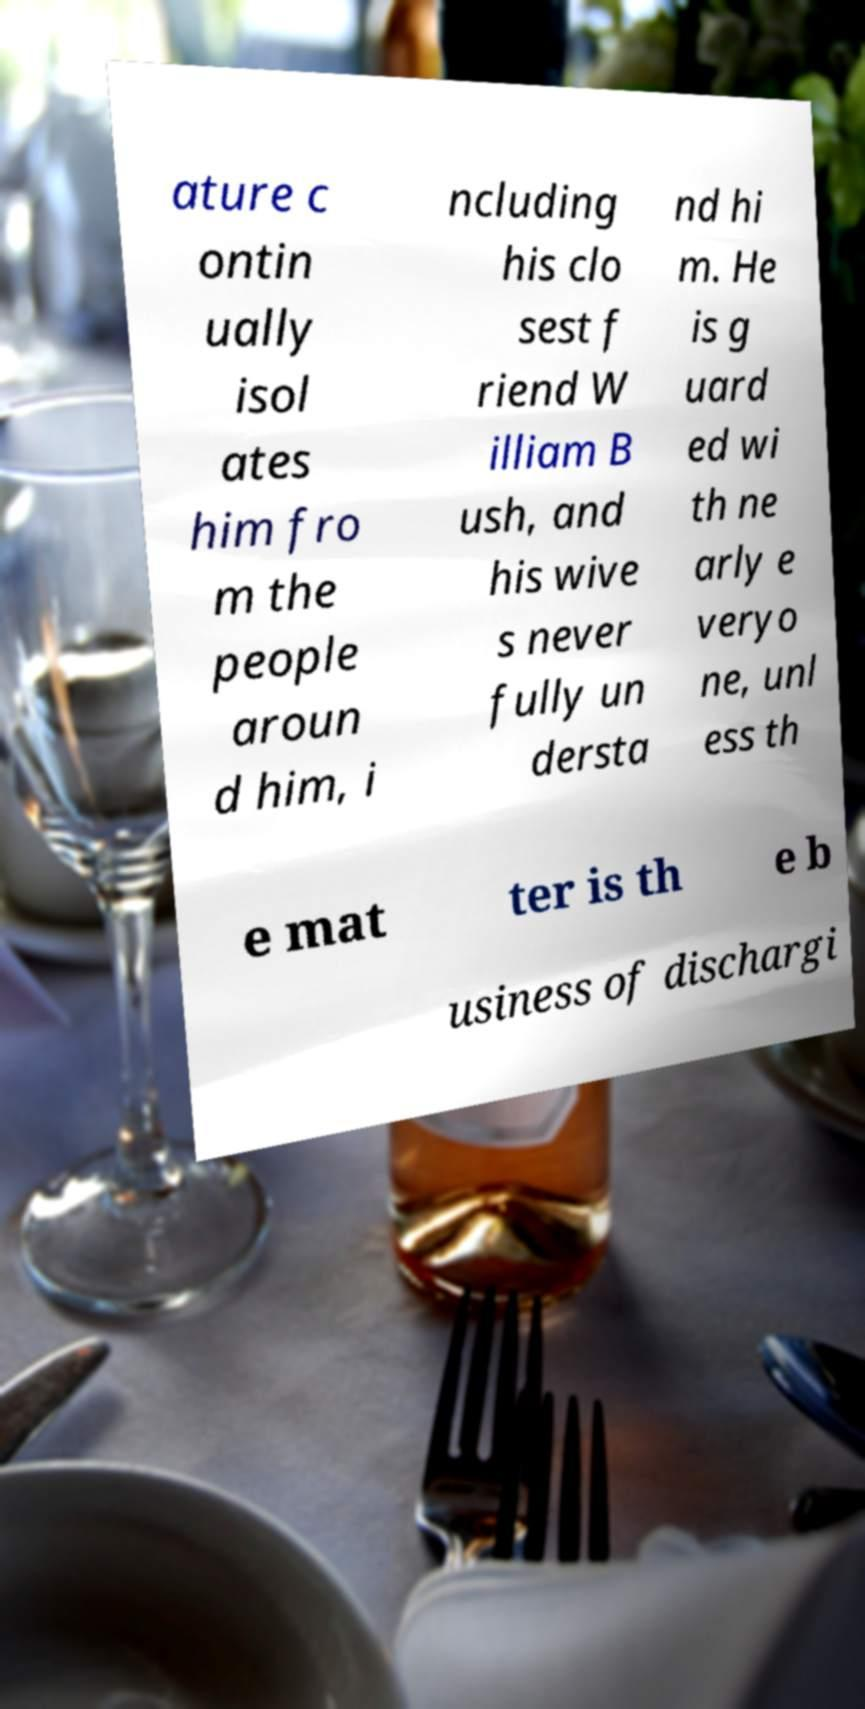Can you accurately transcribe the text from the provided image for me? ature c ontin ually isol ates him fro m the people aroun d him, i ncluding his clo sest f riend W illiam B ush, and his wive s never fully un dersta nd hi m. He is g uard ed wi th ne arly e veryo ne, unl ess th e mat ter is th e b usiness of dischargi 